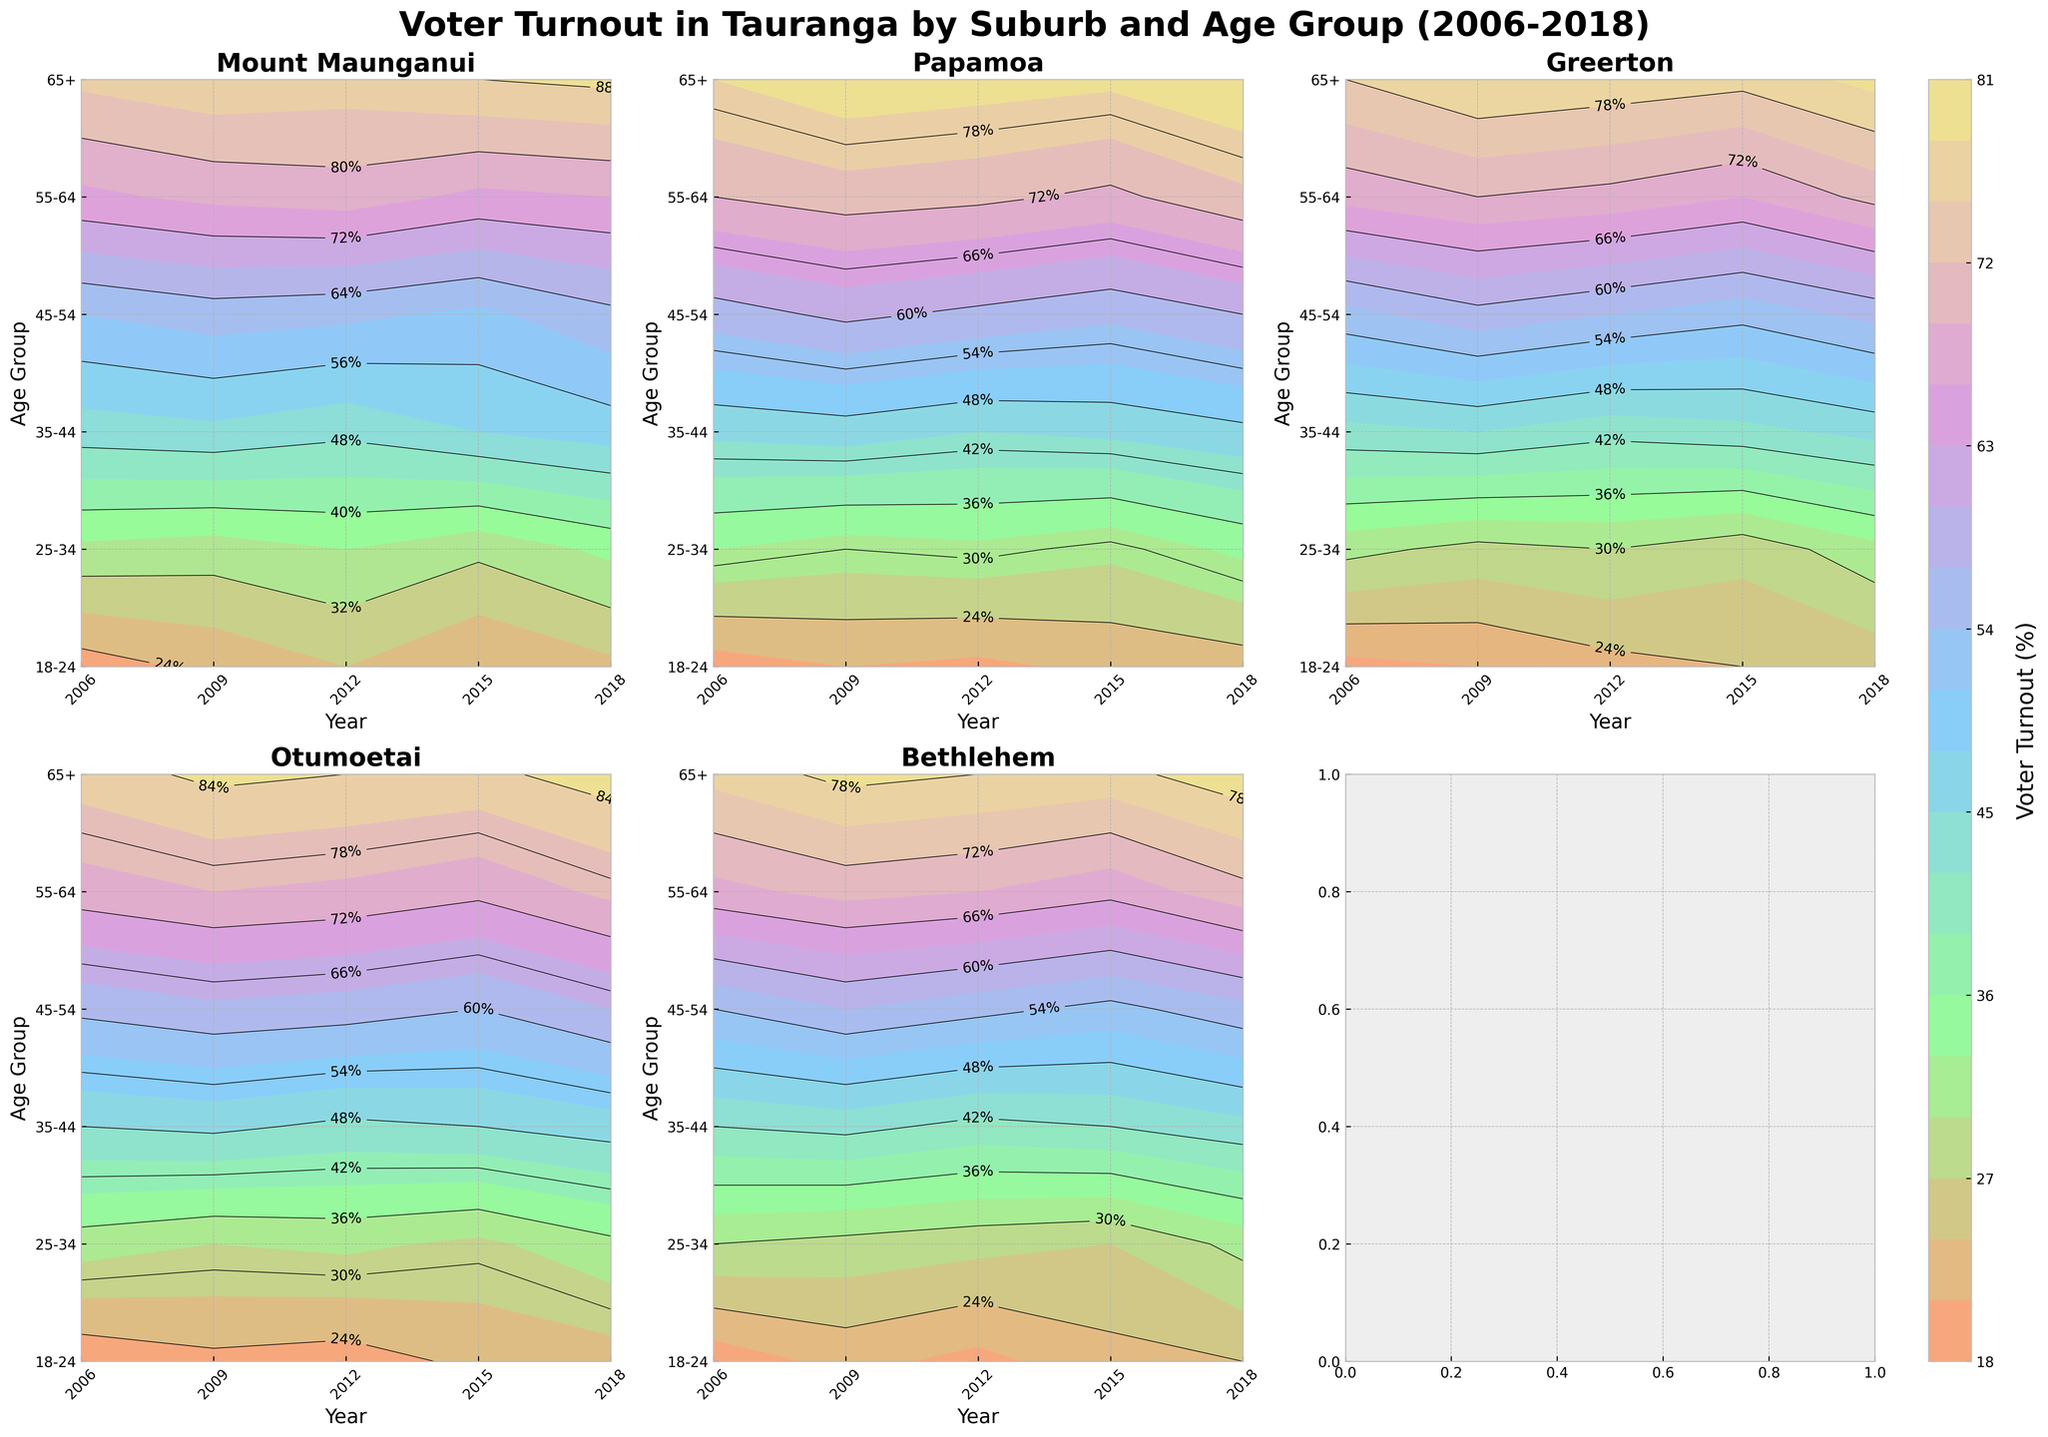What is the title of the plot? The title is located at the top center of the figure. It reads "Voter Turnout in Tauranga by Suburb and Age Group (2006-2018)."
Answer: Voter Turnout in Tauranga by Suburb and Age Group (2006-2018) Which suburb has the highest voter turnout in the 65+ age group in 2018? Refer to each subplot for the specific suburb and look at the contour levels for the 65+ age group along the 2018 vertical line. The highest value contour for the 65+ age group in 2018 is in the Mount Maunganui subplot.
Answer: Mount Maunganui How did the voter turnout for the 18-24 age group in Papamoa change from 2006 to 2018? Examine the contour levels for Papamoa at the 18-24 age group from 2006 to 2018. The contours indicate an increase from around 18% in 2006 to 22% in 2018.
Answer: Increased Between Greerton and Otumoetai, which suburb had a greater increase in voter turnout for the 45-54 age group from 2006 to 2018? Compare the contour levels of both suburbs for the 45-54 age group. In Greerton, the levels increase from 56% to 58%, while in Otumoetai, they increase from 61% to 64%. Thus, Otumoetai shows a greater increase.
Answer: Otumoetai In which suburb did the 35-44 age group consistently have higher voter turnout throughout 2006 to 2018? Analyze all the subplots. For each year between 2006 and 2018, compare the contour levels for the 35-44 age group. The contour levels for the 35-44 age group in Mount Maunganui are consistently higher for every year compared to other suburbs.
Answer: Mount Maunganui Which age group in Bethlehem showed the smallest change in voter turnout from 2006 to 2018? Look at the contour variation for each age group in Bethlehem. The 18-24 age group fluctuates from 19% in 2006 to 24% in 2018. The smallest change is in the 25-34 age group where it varies from 30% in 2006 to 31% in 2018.
Answer: 25-34 Does the 55-64 age group in Otumoetai show an increasing or decreasing trend from 2006 to 2018? Refer to the contour levels for the 55-64 age group in Otumoetai. The contours start at 74% in 2006 and end at 77% in 2018, indicating an increasing trend.
Answer: Increasing Which suburb had the least voter turnout in the 25-34 age group in 2006? Check the contour level of each suburb for the 25-34 age group in 2006. The lowest contour level at this age group in 2006 is seen in Bethlehem, with 30%.
Answer: Bethlehem 